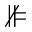<formula> <loc_0><loc_0><loc_500><loc_500>\nVDash</formula> 